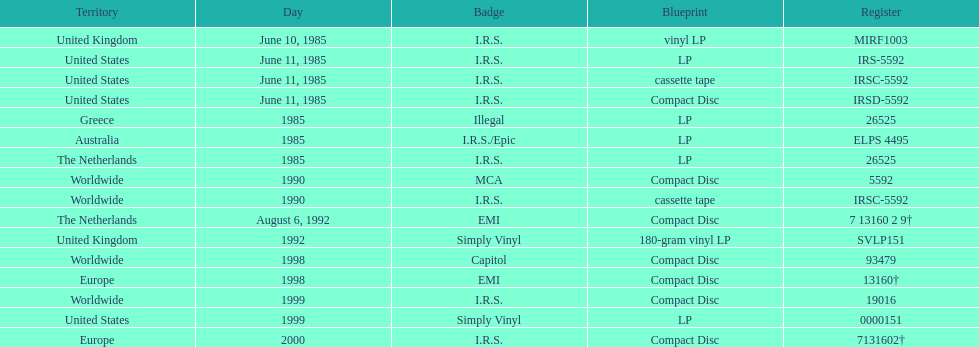Which region was the last to release? Europe. 